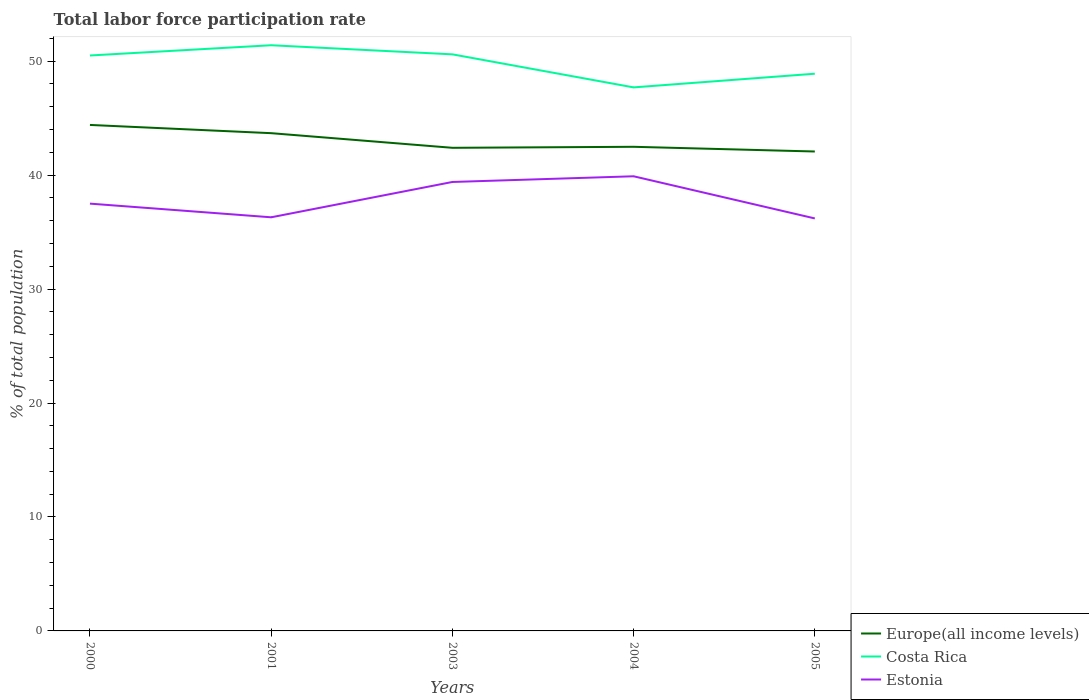Is the number of lines equal to the number of legend labels?
Your response must be concise. Yes. Across all years, what is the maximum total labor force participation rate in Estonia?
Your answer should be very brief. 36.2. In which year was the total labor force participation rate in Europe(all income levels) maximum?
Keep it short and to the point. 2005. What is the total total labor force participation rate in Costa Rica in the graph?
Your response must be concise. 3.7. What is the difference between the highest and the second highest total labor force participation rate in Costa Rica?
Provide a short and direct response. 3.7. Is the total labor force participation rate in Costa Rica strictly greater than the total labor force participation rate in Estonia over the years?
Offer a very short reply. No. How many years are there in the graph?
Ensure brevity in your answer.  5. What is the difference between two consecutive major ticks on the Y-axis?
Your answer should be very brief. 10. Does the graph contain any zero values?
Your answer should be compact. No. Where does the legend appear in the graph?
Your answer should be compact. Bottom right. What is the title of the graph?
Make the answer very short. Total labor force participation rate. Does "China" appear as one of the legend labels in the graph?
Make the answer very short. No. What is the label or title of the X-axis?
Provide a succinct answer. Years. What is the label or title of the Y-axis?
Ensure brevity in your answer.  % of total population. What is the % of total population of Europe(all income levels) in 2000?
Provide a succinct answer. 44.4. What is the % of total population of Costa Rica in 2000?
Provide a succinct answer. 50.5. What is the % of total population of Estonia in 2000?
Give a very brief answer. 37.5. What is the % of total population in Europe(all income levels) in 2001?
Your answer should be compact. 43.68. What is the % of total population in Costa Rica in 2001?
Ensure brevity in your answer.  51.4. What is the % of total population in Estonia in 2001?
Your answer should be compact. 36.3. What is the % of total population of Europe(all income levels) in 2003?
Your answer should be compact. 42.4. What is the % of total population in Costa Rica in 2003?
Give a very brief answer. 50.6. What is the % of total population of Estonia in 2003?
Offer a very short reply. 39.4. What is the % of total population in Europe(all income levels) in 2004?
Your answer should be very brief. 42.49. What is the % of total population in Costa Rica in 2004?
Ensure brevity in your answer.  47.7. What is the % of total population of Estonia in 2004?
Ensure brevity in your answer.  39.9. What is the % of total population of Europe(all income levels) in 2005?
Your answer should be compact. 42.07. What is the % of total population in Costa Rica in 2005?
Give a very brief answer. 48.9. What is the % of total population of Estonia in 2005?
Offer a terse response. 36.2. Across all years, what is the maximum % of total population of Europe(all income levels)?
Offer a terse response. 44.4. Across all years, what is the maximum % of total population of Costa Rica?
Ensure brevity in your answer.  51.4. Across all years, what is the maximum % of total population in Estonia?
Give a very brief answer. 39.9. Across all years, what is the minimum % of total population in Europe(all income levels)?
Provide a succinct answer. 42.07. Across all years, what is the minimum % of total population in Costa Rica?
Offer a very short reply. 47.7. Across all years, what is the minimum % of total population in Estonia?
Keep it short and to the point. 36.2. What is the total % of total population of Europe(all income levels) in the graph?
Provide a short and direct response. 215.05. What is the total % of total population of Costa Rica in the graph?
Your answer should be very brief. 249.1. What is the total % of total population of Estonia in the graph?
Your response must be concise. 189.3. What is the difference between the % of total population of Europe(all income levels) in 2000 and that in 2001?
Offer a very short reply. 0.72. What is the difference between the % of total population of Estonia in 2000 and that in 2001?
Your answer should be compact. 1.2. What is the difference between the % of total population in Europe(all income levels) in 2000 and that in 2003?
Your answer should be very brief. 2.01. What is the difference between the % of total population of Costa Rica in 2000 and that in 2003?
Keep it short and to the point. -0.1. What is the difference between the % of total population in Estonia in 2000 and that in 2003?
Make the answer very short. -1.9. What is the difference between the % of total population of Europe(all income levels) in 2000 and that in 2004?
Give a very brief answer. 1.92. What is the difference between the % of total population of Europe(all income levels) in 2000 and that in 2005?
Your answer should be very brief. 2.33. What is the difference between the % of total population in Estonia in 2000 and that in 2005?
Your response must be concise. 1.3. What is the difference between the % of total population of Europe(all income levels) in 2001 and that in 2003?
Your answer should be compact. 1.28. What is the difference between the % of total population of Costa Rica in 2001 and that in 2003?
Your answer should be compact. 0.8. What is the difference between the % of total population in Estonia in 2001 and that in 2003?
Offer a terse response. -3.1. What is the difference between the % of total population in Europe(all income levels) in 2001 and that in 2004?
Offer a very short reply. 1.2. What is the difference between the % of total population in Estonia in 2001 and that in 2004?
Your answer should be very brief. -3.6. What is the difference between the % of total population of Europe(all income levels) in 2001 and that in 2005?
Keep it short and to the point. 1.61. What is the difference between the % of total population in Europe(all income levels) in 2003 and that in 2004?
Your response must be concise. -0.09. What is the difference between the % of total population of Estonia in 2003 and that in 2004?
Your answer should be very brief. -0.5. What is the difference between the % of total population of Europe(all income levels) in 2003 and that in 2005?
Your response must be concise. 0.32. What is the difference between the % of total population in Europe(all income levels) in 2004 and that in 2005?
Offer a terse response. 0.41. What is the difference between the % of total population in Costa Rica in 2004 and that in 2005?
Provide a succinct answer. -1.2. What is the difference between the % of total population in Estonia in 2004 and that in 2005?
Make the answer very short. 3.7. What is the difference between the % of total population in Europe(all income levels) in 2000 and the % of total population in Costa Rica in 2001?
Offer a very short reply. -7. What is the difference between the % of total population in Europe(all income levels) in 2000 and the % of total population in Estonia in 2001?
Keep it short and to the point. 8.1. What is the difference between the % of total population in Costa Rica in 2000 and the % of total population in Estonia in 2001?
Make the answer very short. 14.2. What is the difference between the % of total population in Europe(all income levels) in 2000 and the % of total population in Costa Rica in 2003?
Ensure brevity in your answer.  -6.2. What is the difference between the % of total population in Europe(all income levels) in 2000 and the % of total population in Estonia in 2003?
Your response must be concise. 5. What is the difference between the % of total population of Costa Rica in 2000 and the % of total population of Estonia in 2003?
Ensure brevity in your answer.  11.1. What is the difference between the % of total population of Europe(all income levels) in 2000 and the % of total population of Costa Rica in 2004?
Your answer should be very brief. -3.3. What is the difference between the % of total population of Europe(all income levels) in 2000 and the % of total population of Estonia in 2004?
Offer a terse response. 4.5. What is the difference between the % of total population of Costa Rica in 2000 and the % of total population of Estonia in 2004?
Offer a very short reply. 10.6. What is the difference between the % of total population in Europe(all income levels) in 2000 and the % of total population in Costa Rica in 2005?
Ensure brevity in your answer.  -4.5. What is the difference between the % of total population in Europe(all income levels) in 2000 and the % of total population in Estonia in 2005?
Ensure brevity in your answer.  8.2. What is the difference between the % of total population in Costa Rica in 2000 and the % of total population in Estonia in 2005?
Your response must be concise. 14.3. What is the difference between the % of total population of Europe(all income levels) in 2001 and the % of total population of Costa Rica in 2003?
Keep it short and to the point. -6.92. What is the difference between the % of total population of Europe(all income levels) in 2001 and the % of total population of Estonia in 2003?
Provide a succinct answer. 4.28. What is the difference between the % of total population in Costa Rica in 2001 and the % of total population in Estonia in 2003?
Make the answer very short. 12. What is the difference between the % of total population in Europe(all income levels) in 2001 and the % of total population in Costa Rica in 2004?
Make the answer very short. -4.02. What is the difference between the % of total population of Europe(all income levels) in 2001 and the % of total population of Estonia in 2004?
Your answer should be very brief. 3.78. What is the difference between the % of total population of Europe(all income levels) in 2001 and the % of total population of Costa Rica in 2005?
Ensure brevity in your answer.  -5.22. What is the difference between the % of total population of Europe(all income levels) in 2001 and the % of total population of Estonia in 2005?
Offer a terse response. 7.48. What is the difference between the % of total population in Costa Rica in 2001 and the % of total population in Estonia in 2005?
Your answer should be compact. 15.2. What is the difference between the % of total population of Europe(all income levels) in 2003 and the % of total population of Costa Rica in 2004?
Keep it short and to the point. -5.3. What is the difference between the % of total population of Europe(all income levels) in 2003 and the % of total population of Estonia in 2004?
Your response must be concise. 2.5. What is the difference between the % of total population in Costa Rica in 2003 and the % of total population in Estonia in 2004?
Give a very brief answer. 10.7. What is the difference between the % of total population in Europe(all income levels) in 2003 and the % of total population in Costa Rica in 2005?
Provide a short and direct response. -6.5. What is the difference between the % of total population of Europe(all income levels) in 2003 and the % of total population of Estonia in 2005?
Give a very brief answer. 6.2. What is the difference between the % of total population in Costa Rica in 2003 and the % of total population in Estonia in 2005?
Your response must be concise. 14.4. What is the difference between the % of total population in Europe(all income levels) in 2004 and the % of total population in Costa Rica in 2005?
Provide a short and direct response. -6.41. What is the difference between the % of total population in Europe(all income levels) in 2004 and the % of total population in Estonia in 2005?
Provide a succinct answer. 6.29. What is the difference between the % of total population of Costa Rica in 2004 and the % of total population of Estonia in 2005?
Your answer should be compact. 11.5. What is the average % of total population of Europe(all income levels) per year?
Your answer should be very brief. 43.01. What is the average % of total population of Costa Rica per year?
Provide a short and direct response. 49.82. What is the average % of total population of Estonia per year?
Your answer should be very brief. 37.86. In the year 2000, what is the difference between the % of total population of Europe(all income levels) and % of total population of Costa Rica?
Offer a terse response. -6.1. In the year 2000, what is the difference between the % of total population in Europe(all income levels) and % of total population in Estonia?
Provide a succinct answer. 6.9. In the year 2001, what is the difference between the % of total population of Europe(all income levels) and % of total population of Costa Rica?
Give a very brief answer. -7.72. In the year 2001, what is the difference between the % of total population in Europe(all income levels) and % of total population in Estonia?
Ensure brevity in your answer.  7.38. In the year 2003, what is the difference between the % of total population of Europe(all income levels) and % of total population of Costa Rica?
Make the answer very short. -8.2. In the year 2003, what is the difference between the % of total population of Europe(all income levels) and % of total population of Estonia?
Ensure brevity in your answer.  3. In the year 2004, what is the difference between the % of total population of Europe(all income levels) and % of total population of Costa Rica?
Offer a terse response. -5.21. In the year 2004, what is the difference between the % of total population of Europe(all income levels) and % of total population of Estonia?
Keep it short and to the point. 2.59. In the year 2004, what is the difference between the % of total population of Costa Rica and % of total population of Estonia?
Provide a short and direct response. 7.8. In the year 2005, what is the difference between the % of total population of Europe(all income levels) and % of total population of Costa Rica?
Give a very brief answer. -6.83. In the year 2005, what is the difference between the % of total population of Europe(all income levels) and % of total population of Estonia?
Keep it short and to the point. 5.87. In the year 2005, what is the difference between the % of total population of Costa Rica and % of total population of Estonia?
Offer a terse response. 12.7. What is the ratio of the % of total population in Europe(all income levels) in 2000 to that in 2001?
Offer a very short reply. 1.02. What is the ratio of the % of total population of Costa Rica in 2000 to that in 2001?
Offer a terse response. 0.98. What is the ratio of the % of total population in Estonia in 2000 to that in 2001?
Provide a short and direct response. 1.03. What is the ratio of the % of total population in Europe(all income levels) in 2000 to that in 2003?
Offer a terse response. 1.05. What is the ratio of the % of total population of Costa Rica in 2000 to that in 2003?
Keep it short and to the point. 1. What is the ratio of the % of total population in Estonia in 2000 to that in 2003?
Make the answer very short. 0.95. What is the ratio of the % of total population in Europe(all income levels) in 2000 to that in 2004?
Your answer should be compact. 1.05. What is the ratio of the % of total population in Costa Rica in 2000 to that in 2004?
Offer a terse response. 1.06. What is the ratio of the % of total population of Estonia in 2000 to that in 2004?
Make the answer very short. 0.94. What is the ratio of the % of total population in Europe(all income levels) in 2000 to that in 2005?
Keep it short and to the point. 1.06. What is the ratio of the % of total population of Costa Rica in 2000 to that in 2005?
Provide a succinct answer. 1.03. What is the ratio of the % of total population in Estonia in 2000 to that in 2005?
Provide a short and direct response. 1.04. What is the ratio of the % of total population of Europe(all income levels) in 2001 to that in 2003?
Make the answer very short. 1.03. What is the ratio of the % of total population of Costa Rica in 2001 to that in 2003?
Give a very brief answer. 1.02. What is the ratio of the % of total population of Estonia in 2001 to that in 2003?
Your answer should be compact. 0.92. What is the ratio of the % of total population of Europe(all income levels) in 2001 to that in 2004?
Your answer should be compact. 1.03. What is the ratio of the % of total population of Costa Rica in 2001 to that in 2004?
Offer a very short reply. 1.08. What is the ratio of the % of total population of Estonia in 2001 to that in 2004?
Your response must be concise. 0.91. What is the ratio of the % of total population in Europe(all income levels) in 2001 to that in 2005?
Your answer should be very brief. 1.04. What is the ratio of the % of total population in Costa Rica in 2001 to that in 2005?
Ensure brevity in your answer.  1.05. What is the ratio of the % of total population of Estonia in 2001 to that in 2005?
Your answer should be compact. 1. What is the ratio of the % of total population in Costa Rica in 2003 to that in 2004?
Provide a short and direct response. 1.06. What is the ratio of the % of total population in Estonia in 2003 to that in 2004?
Provide a succinct answer. 0.99. What is the ratio of the % of total population of Europe(all income levels) in 2003 to that in 2005?
Your response must be concise. 1.01. What is the ratio of the % of total population of Costa Rica in 2003 to that in 2005?
Offer a very short reply. 1.03. What is the ratio of the % of total population of Estonia in 2003 to that in 2005?
Ensure brevity in your answer.  1.09. What is the ratio of the % of total population in Europe(all income levels) in 2004 to that in 2005?
Your answer should be very brief. 1.01. What is the ratio of the % of total population in Costa Rica in 2004 to that in 2005?
Make the answer very short. 0.98. What is the ratio of the % of total population of Estonia in 2004 to that in 2005?
Offer a very short reply. 1.1. What is the difference between the highest and the second highest % of total population of Europe(all income levels)?
Give a very brief answer. 0.72. What is the difference between the highest and the second highest % of total population of Estonia?
Make the answer very short. 0.5. What is the difference between the highest and the lowest % of total population in Europe(all income levels)?
Offer a very short reply. 2.33. What is the difference between the highest and the lowest % of total population of Estonia?
Offer a very short reply. 3.7. 